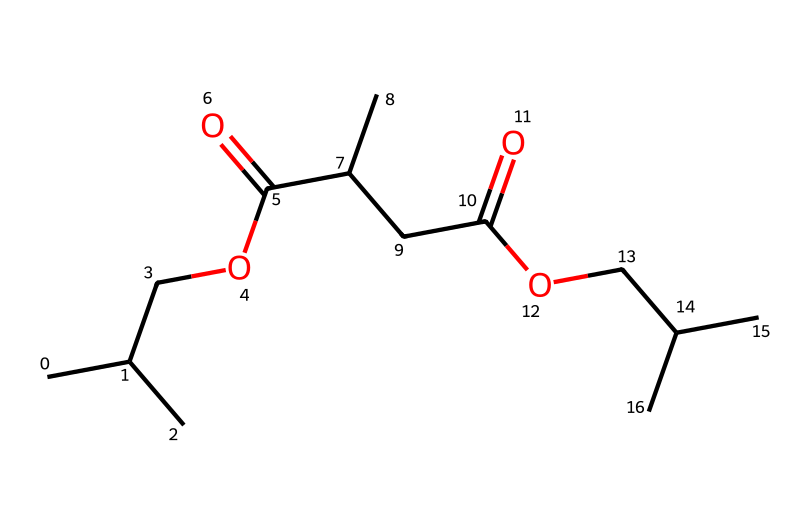How many carbon atoms are in this compound? By examining the SMILES representation, we can count the number of 'C' letters, which represent carbon atoms. The total count includes both the terminal and branching carbon atoms. There are a total of 12 carbon atoms present.
Answer: 12 What functional group is indicated by the "C(=O)" part of the SMILES? The "C(=O)" notation indicates a carbonyl functional group, where a carbon atom is double-bonded to an oxygen atom. This suggests the presence of either a ketone or an ester group in the structure, depending on the surrounding atoms.
Answer: carbonyl How many ester linkages are present in this molecule? The presence of ester linkages can be identified by looking for the "C(=O)O" structure, which signifies an ester bond. In this SMILES, there are two instances of "C(=O)O," indicating that there are two ester linkages.
Answer: 2 Is this molecule likely to be hydrophilic or hydrophobic? The presence of polar functional groups such as esters and acids suggests that the molecule can interact well with water, thus making it more hydrophilic. However, the larger hydrocarbon chains might introduce some hydrophobic characteristics. Overall, the balance leans toward hydrophilic due to the several polar groups.
Answer: hydrophilic Which two functional groups are shown to be present in this molecule? By analyzing the SMILES, we identify two distinct functional groups: the ester (C(=O)O) and the carboxylic acid (C(=O)O) groups. Both enhance the biodegradable nature of the plastic by introducing polarity and potential degradation sites.
Answer: ester and carboxylic acid 